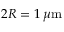<formula> <loc_0><loc_0><loc_500><loc_500>2 R = 1 \, \mu m</formula> 